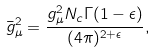<formula> <loc_0><loc_0><loc_500><loc_500>\bar { g } _ { \mu } ^ { 2 } = \frac { g _ { \mu } ^ { 2 } N _ { c } \Gamma ( 1 - \epsilon ) } { ( 4 \pi ) ^ { 2 + { \epsilon } } } ,</formula> 